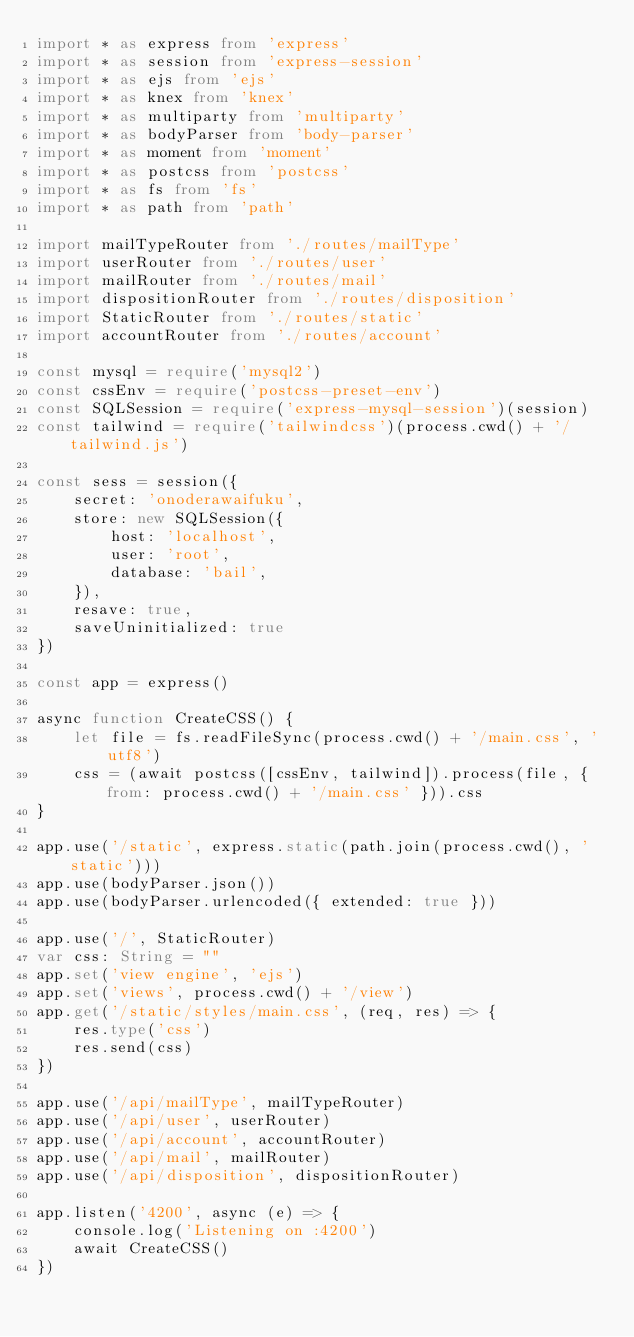Convert code to text. <code><loc_0><loc_0><loc_500><loc_500><_TypeScript_>import * as express from 'express'
import * as session from 'express-session'
import * as ejs from 'ejs'
import * as knex from 'knex'
import * as multiparty from 'multiparty'
import * as bodyParser from 'body-parser'
import * as moment from 'moment'
import * as postcss from 'postcss'
import * as fs from 'fs'
import * as path from 'path'

import mailTypeRouter from './routes/mailType'
import userRouter from './routes/user'
import mailRouter from './routes/mail'
import dispositionRouter from './routes/disposition'
import StaticRouter from './routes/static'
import accountRouter from './routes/account'

const mysql = require('mysql2')
const cssEnv = require('postcss-preset-env')
const SQLSession = require('express-mysql-session')(session)
const tailwind = require('tailwindcss')(process.cwd() + '/tailwind.js')

const sess = session({
    secret: 'onoderawaifuku',
    store: new SQLSession({
        host: 'localhost',
        user: 'root',
        database: 'bail',
    }),
    resave: true,
    saveUninitialized: true
})

const app = express()

async function CreateCSS() {
    let file = fs.readFileSync(process.cwd() + '/main.css', 'utf8')
    css = (await postcss([cssEnv, tailwind]).process(file, { from: process.cwd() + '/main.css' })).css
}

app.use('/static', express.static(path.join(process.cwd(), 'static')))
app.use(bodyParser.json())
app.use(bodyParser.urlencoded({ extended: true }))

app.use('/', StaticRouter)
var css: String = ""
app.set('view engine', 'ejs')
app.set('views', process.cwd() + '/view')
app.get('/static/styles/main.css', (req, res) => {
    res.type('css')
    res.send(css)
})

app.use('/api/mailType', mailTypeRouter)
app.use('/api/user', userRouter)
app.use('/api/account', accountRouter)
app.use('/api/mail', mailRouter)
app.use('/api/disposition', dispositionRouter)

app.listen('4200', async (e) => {
    console.log('Listening on :4200')
    await CreateCSS()
})
</code> 